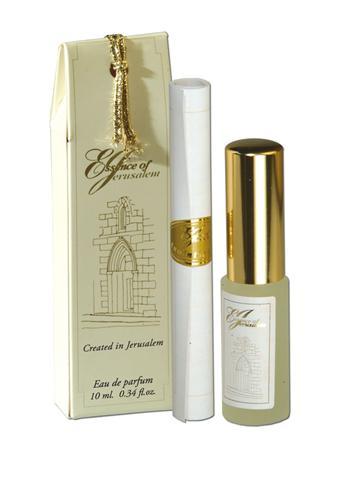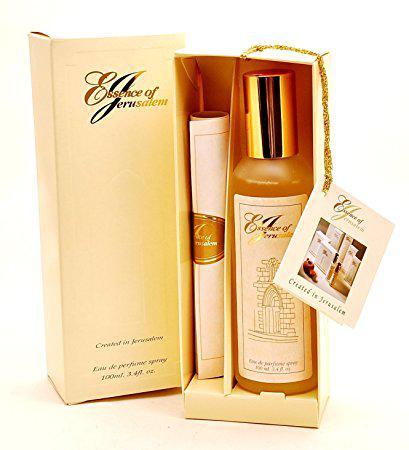The first image is the image on the left, the second image is the image on the right. Assess this claim about the two images: "Each perfume set includes long, narrow cylinder and a bottle with a metal cap.". Correct or not? Answer yes or no. Yes. 